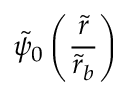Convert formula to latex. <formula><loc_0><loc_0><loc_500><loc_500>\tilde { \psi } _ { 0 } \left ( \frac { \tilde { r } } { \tilde { r } _ { b } } \right )</formula> 